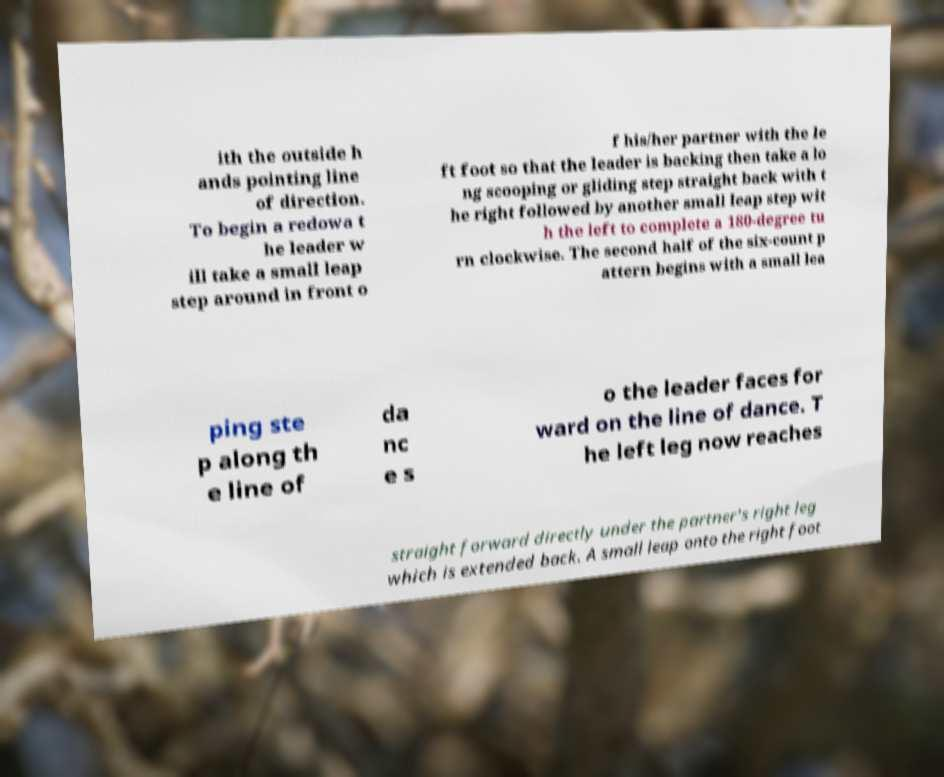Please identify and transcribe the text found in this image. ith the outside h ands pointing line of direction. To begin a redowa t he leader w ill take a small leap step around in front o f his/her partner with the le ft foot so that the leader is backing then take a lo ng scooping or gliding step straight back with t he right followed by another small leap step wit h the left to complete a 180-degree tu rn clockwise. The second half of the six-count p attern begins with a small lea ping ste p along th e line of da nc e s o the leader faces for ward on the line of dance. T he left leg now reaches straight forward directly under the partner's right leg which is extended back. A small leap onto the right foot 